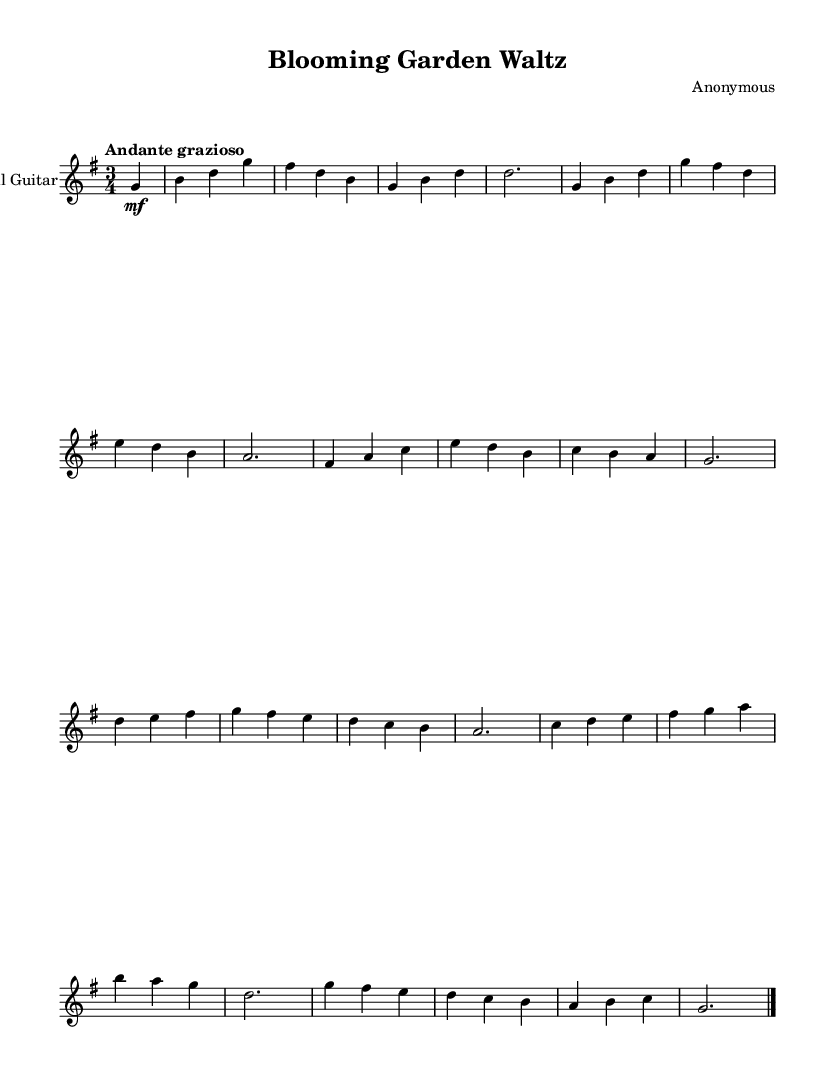What is the time signature of this music? The time signature is indicated at the beginning of the score. It shows "3/4," meaning there are three beats per measure, and each quarter note gets one beat.
Answer: 3/4 What is the key signature of this music? The key signature appears at the beginning of the score, showing one sharp (F-sharp), which indicates that the piece is in G major.
Answer: G major What is the indicated tempo for this composition? The tempo marking is found below the title. It states "Andante grazioso," which translates to a moderately slow and graceful tempo.
Answer: Andante grazioso How many sections are present in this composition? By analyzing the structure of the music, there are two main sections labeled A and B, followed by a coda. Therefore, we count Section A, Section B, and the Coda.
Answer: Three What is the dynamic marking for the introduction? In the introduction, the dynamic marking is noted as "mf," which stands for "mezzo forte," indicating a moderately loud volume at the start.
Answer: mezzo forte Which chord is played at the end of the composition? The final measure of the composition concludes with a "g" chord, followed by the bar line, indicating the end of the piece.
Answer: g What does the title of this composition evoke? The title "Blooming Garden Waltz" suggests themes of nature and beauty, likening the flowing music to the grace and elegance of blooming flowers, fitting for a romantic style.
Answer: Blooming Garden Waltz 